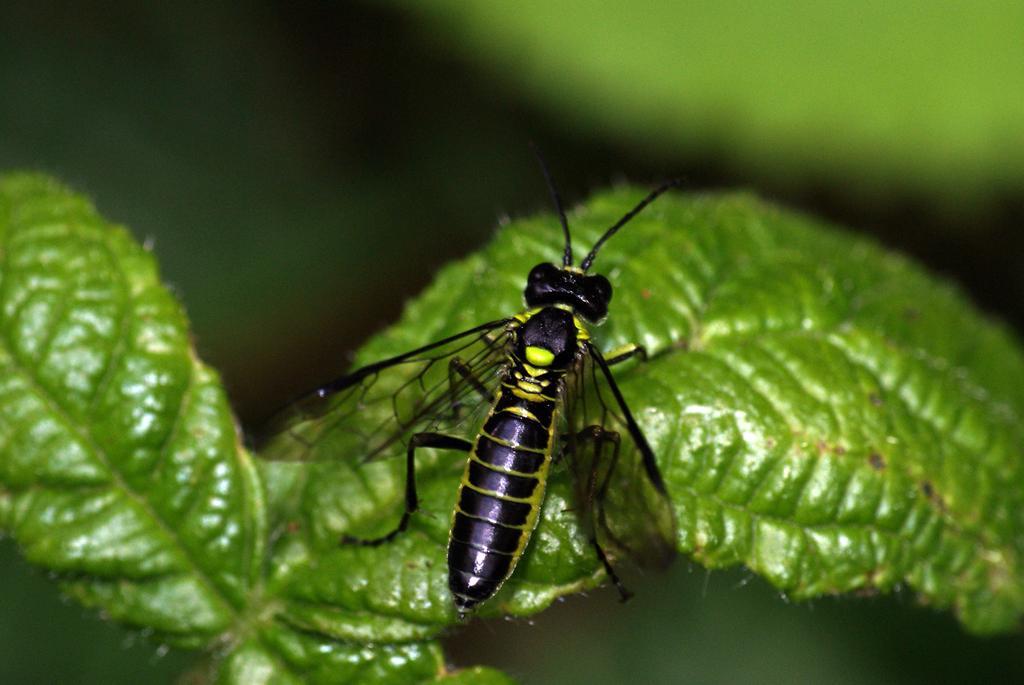Describe this image in one or two sentences. Here I can see a black color fly on a leaf. The background is blurred. 